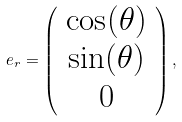Convert formula to latex. <formula><loc_0><loc_0><loc_500><loc_500>e _ { r } = \left ( \begin{array} { c } \cos ( \theta ) \\ \sin ( \theta ) \\ 0 \end{array} \right ) ,</formula> 